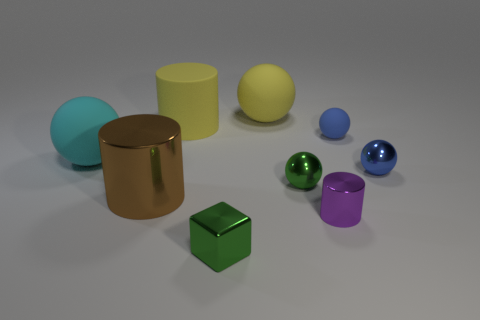Subtract 2 spheres. How many spheres are left? 3 Subtract all small green spheres. How many spheres are left? 4 Subtract all green spheres. How many spheres are left? 4 Subtract all red balls. Subtract all gray cubes. How many balls are left? 5 Add 1 green blocks. How many objects exist? 10 Subtract all balls. How many objects are left? 4 Subtract all small red metallic spheres. Subtract all green cubes. How many objects are left? 8 Add 1 tiny green cubes. How many tiny green cubes are left? 2 Add 5 big green things. How many big green things exist? 5 Subtract 0 blue blocks. How many objects are left? 9 